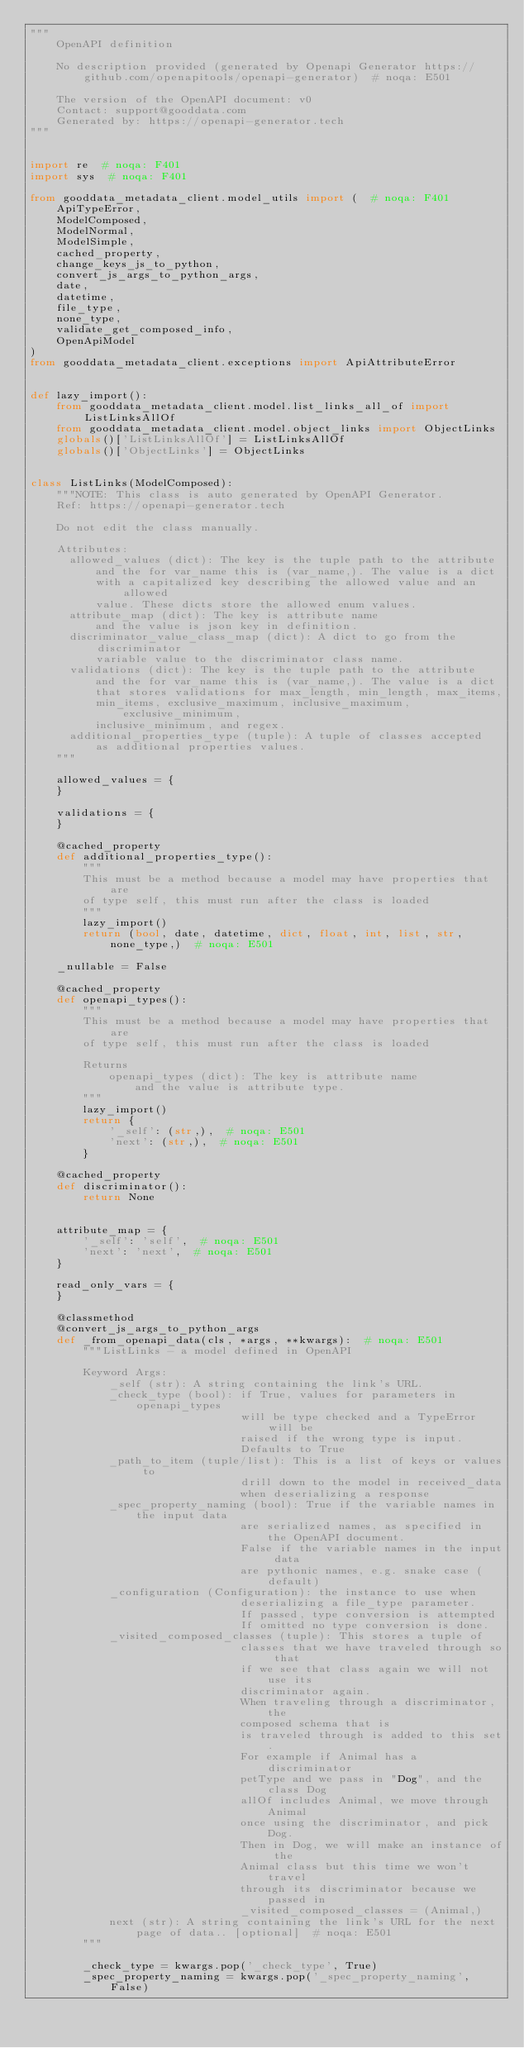Convert code to text. <code><loc_0><loc_0><loc_500><loc_500><_Python_>"""
    OpenAPI definition

    No description provided (generated by Openapi Generator https://github.com/openapitools/openapi-generator)  # noqa: E501

    The version of the OpenAPI document: v0
    Contact: support@gooddata.com
    Generated by: https://openapi-generator.tech
"""


import re  # noqa: F401
import sys  # noqa: F401

from gooddata_metadata_client.model_utils import (  # noqa: F401
    ApiTypeError,
    ModelComposed,
    ModelNormal,
    ModelSimple,
    cached_property,
    change_keys_js_to_python,
    convert_js_args_to_python_args,
    date,
    datetime,
    file_type,
    none_type,
    validate_get_composed_info,
    OpenApiModel
)
from gooddata_metadata_client.exceptions import ApiAttributeError


def lazy_import():
    from gooddata_metadata_client.model.list_links_all_of import ListLinksAllOf
    from gooddata_metadata_client.model.object_links import ObjectLinks
    globals()['ListLinksAllOf'] = ListLinksAllOf
    globals()['ObjectLinks'] = ObjectLinks


class ListLinks(ModelComposed):
    """NOTE: This class is auto generated by OpenAPI Generator.
    Ref: https://openapi-generator.tech

    Do not edit the class manually.

    Attributes:
      allowed_values (dict): The key is the tuple path to the attribute
          and the for var_name this is (var_name,). The value is a dict
          with a capitalized key describing the allowed value and an allowed
          value. These dicts store the allowed enum values.
      attribute_map (dict): The key is attribute name
          and the value is json key in definition.
      discriminator_value_class_map (dict): A dict to go from the discriminator
          variable value to the discriminator class name.
      validations (dict): The key is the tuple path to the attribute
          and the for var_name this is (var_name,). The value is a dict
          that stores validations for max_length, min_length, max_items,
          min_items, exclusive_maximum, inclusive_maximum, exclusive_minimum,
          inclusive_minimum, and regex.
      additional_properties_type (tuple): A tuple of classes accepted
          as additional properties values.
    """

    allowed_values = {
    }

    validations = {
    }

    @cached_property
    def additional_properties_type():
        """
        This must be a method because a model may have properties that are
        of type self, this must run after the class is loaded
        """
        lazy_import()
        return (bool, date, datetime, dict, float, int, list, str, none_type,)  # noqa: E501

    _nullable = False

    @cached_property
    def openapi_types():
        """
        This must be a method because a model may have properties that are
        of type self, this must run after the class is loaded

        Returns
            openapi_types (dict): The key is attribute name
                and the value is attribute type.
        """
        lazy_import()
        return {
            '_self': (str,),  # noqa: E501
            'next': (str,),  # noqa: E501
        }

    @cached_property
    def discriminator():
        return None


    attribute_map = {
        '_self': 'self',  # noqa: E501
        'next': 'next',  # noqa: E501
    }

    read_only_vars = {
    }

    @classmethod
    @convert_js_args_to_python_args
    def _from_openapi_data(cls, *args, **kwargs):  # noqa: E501
        """ListLinks - a model defined in OpenAPI

        Keyword Args:
            _self (str): A string containing the link's URL.
            _check_type (bool): if True, values for parameters in openapi_types
                                will be type checked and a TypeError will be
                                raised if the wrong type is input.
                                Defaults to True
            _path_to_item (tuple/list): This is a list of keys or values to
                                drill down to the model in received_data
                                when deserializing a response
            _spec_property_naming (bool): True if the variable names in the input data
                                are serialized names, as specified in the OpenAPI document.
                                False if the variable names in the input data
                                are pythonic names, e.g. snake case (default)
            _configuration (Configuration): the instance to use when
                                deserializing a file_type parameter.
                                If passed, type conversion is attempted
                                If omitted no type conversion is done.
            _visited_composed_classes (tuple): This stores a tuple of
                                classes that we have traveled through so that
                                if we see that class again we will not use its
                                discriminator again.
                                When traveling through a discriminator, the
                                composed schema that is
                                is traveled through is added to this set.
                                For example if Animal has a discriminator
                                petType and we pass in "Dog", and the class Dog
                                allOf includes Animal, we move through Animal
                                once using the discriminator, and pick Dog.
                                Then in Dog, we will make an instance of the
                                Animal class but this time we won't travel
                                through its discriminator because we passed in
                                _visited_composed_classes = (Animal,)
            next (str): A string containing the link's URL for the next page of data.. [optional]  # noqa: E501
        """

        _check_type = kwargs.pop('_check_type', True)
        _spec_property_naming = kwargs.pop('_spec_property_naming', False)</code> 